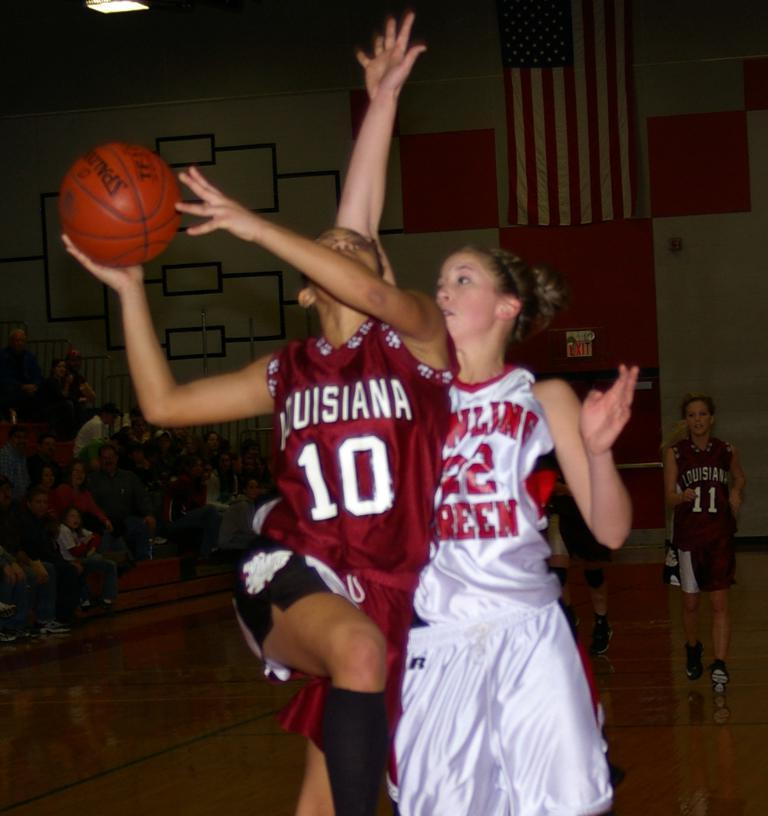<image>
Describe the image concisely. Player number 10 for Louisiana about to shoot a layup. 